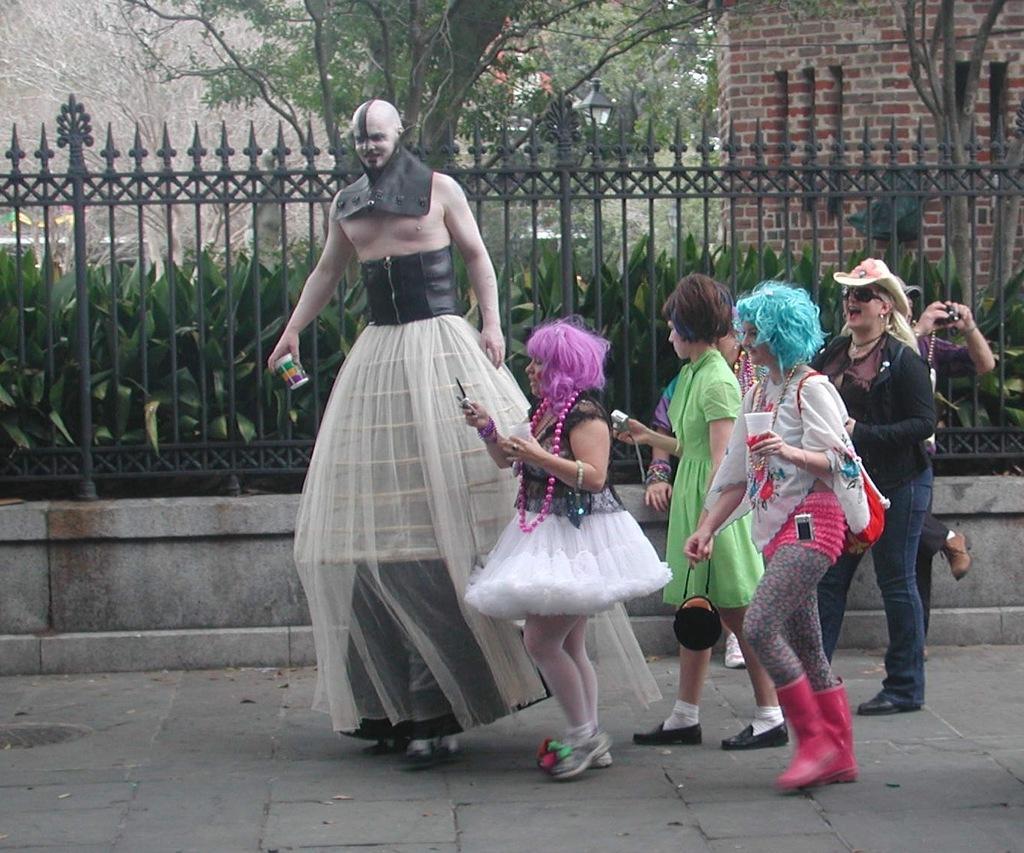In one or two sentences, can you explain what this image depicts? In this image we can see persons wearing costumes standing on the floor. In the background there are trees, walls, street light, plants and an iron grill. 